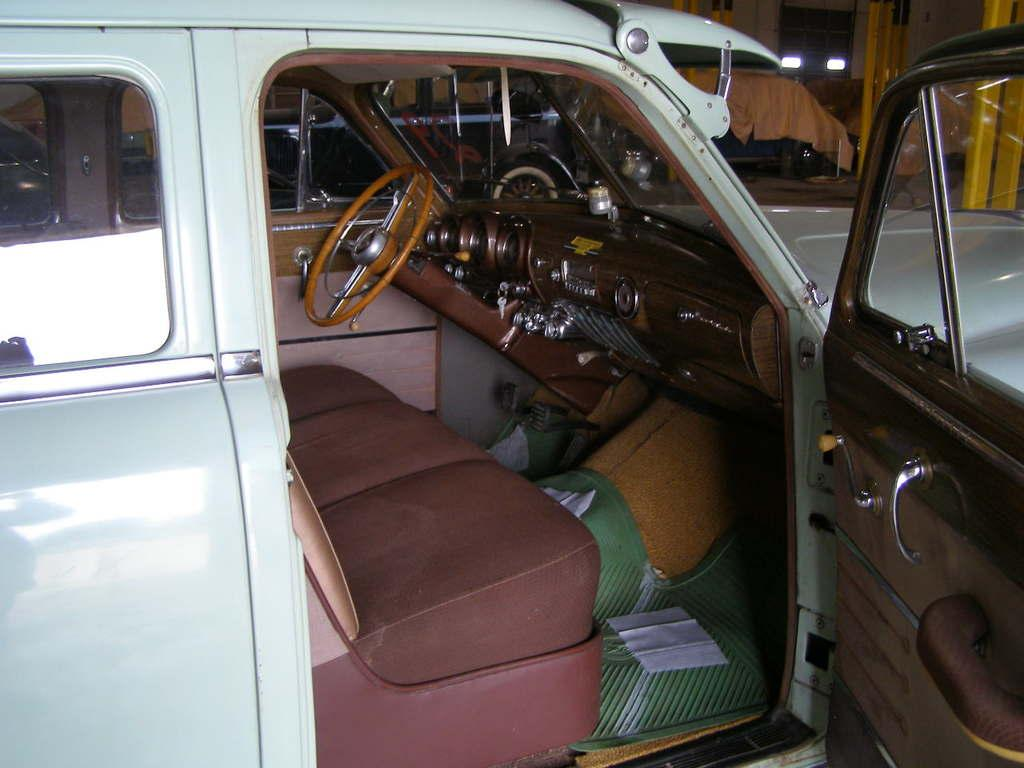What is the main subject of the image? There is a vehicle in the image. Can you describe the surrounding environment in the image? There are other vehicles visible behind the first vehicle. What type of art can be seen on the side of the vehicle in the image? There is no art visible on the side of the vehicle in the image. What is the voice of the driver in the vehicle in the image? There is no information about the driver or their voice in the image. 